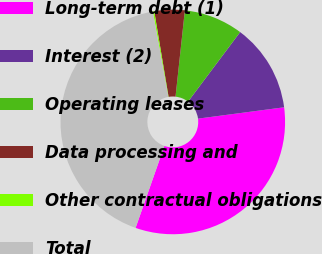Convert chart to OTSL. <chart><loc_0><loc_0><loc_500><loc_500><pie_chart><fcel>Long-term debt (1)<fcel>Interest (2)<fcel>Operating leases<fcel>Data processing and<fcel>Other contractual obligations<fcel>Total<nl><fcel>32.46%<fcel>12.68%<fcel>8.52%<fcel>4.36%<fcel>0.2%<fcel>41.78%<nl></chart> 